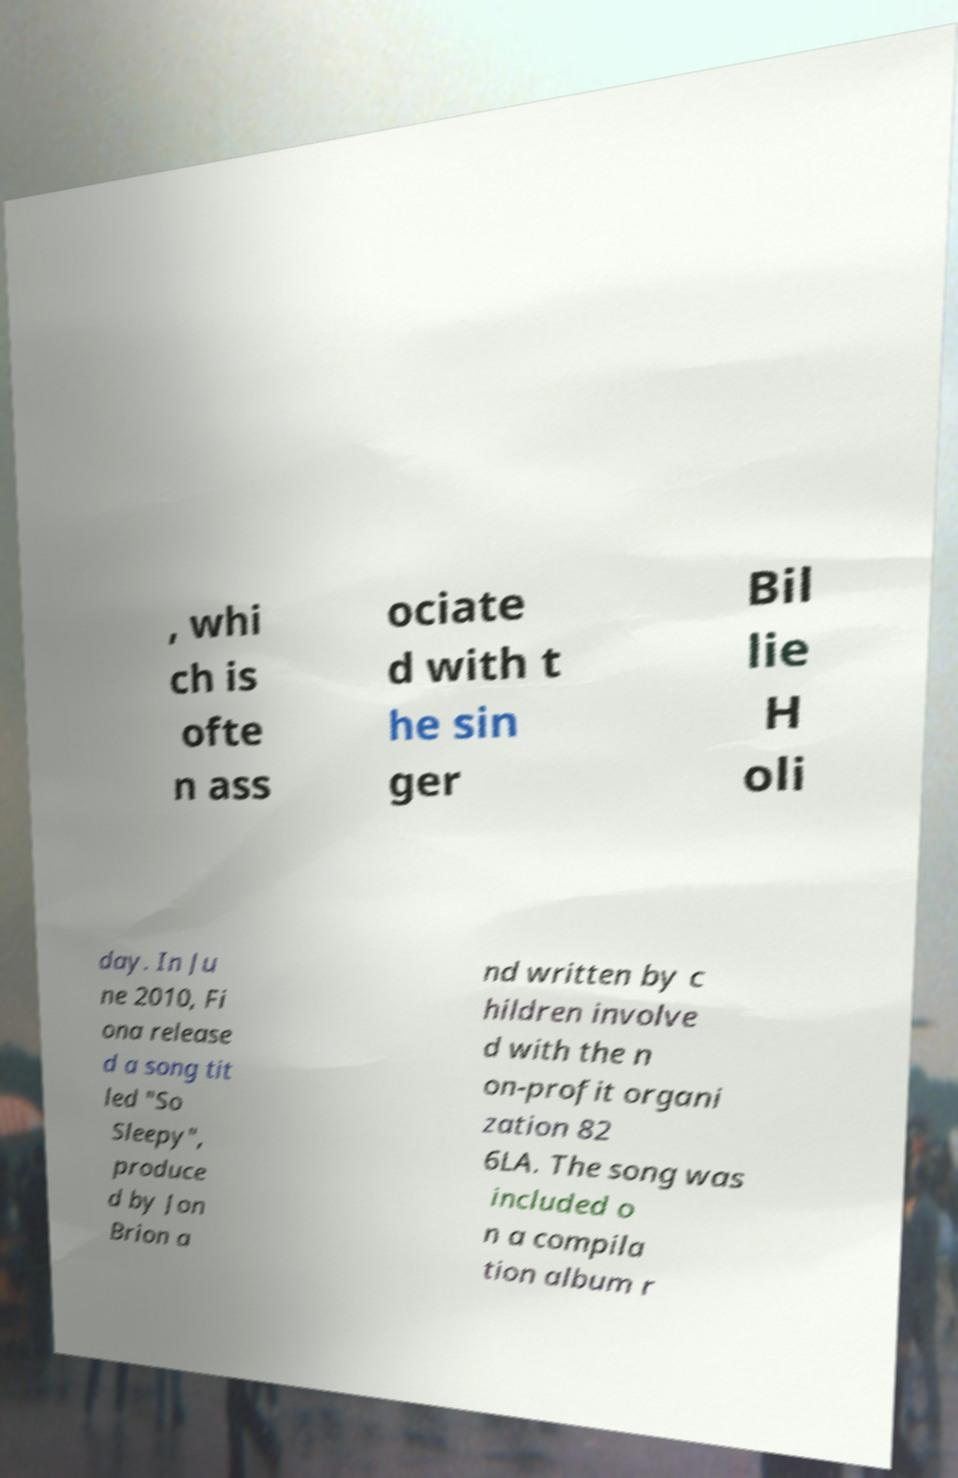There's text embedded in this image that I need extracted. Can you transcribe it verbatim? , whi ch is ofte n ass ociate d with t he sin ger Bil lie H oli day. In Ju ne 2010, Fi ona release d a song tit led "So Sleepy", produce d by Jon Brion a nd written by c hildren involve d with the n on-profit organi zation 82 6LA. The song was included o n a compila tion album r 